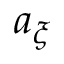Convert formula to latex. <formula><loc_0><loc_0><loc_500><loc_500>a _ { \xi }</formula> 